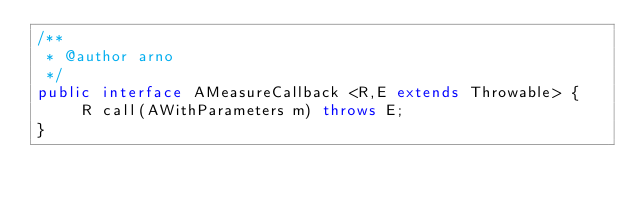Convert code to text. <code><loc_0><loc_0><loc_500><loc_500><_Java_>/**
 * @author arno
 */
public interface AMeasureCallback <R,E extends Throwable> {
     R call(AWithParameters m) throws E;
}
</code> 